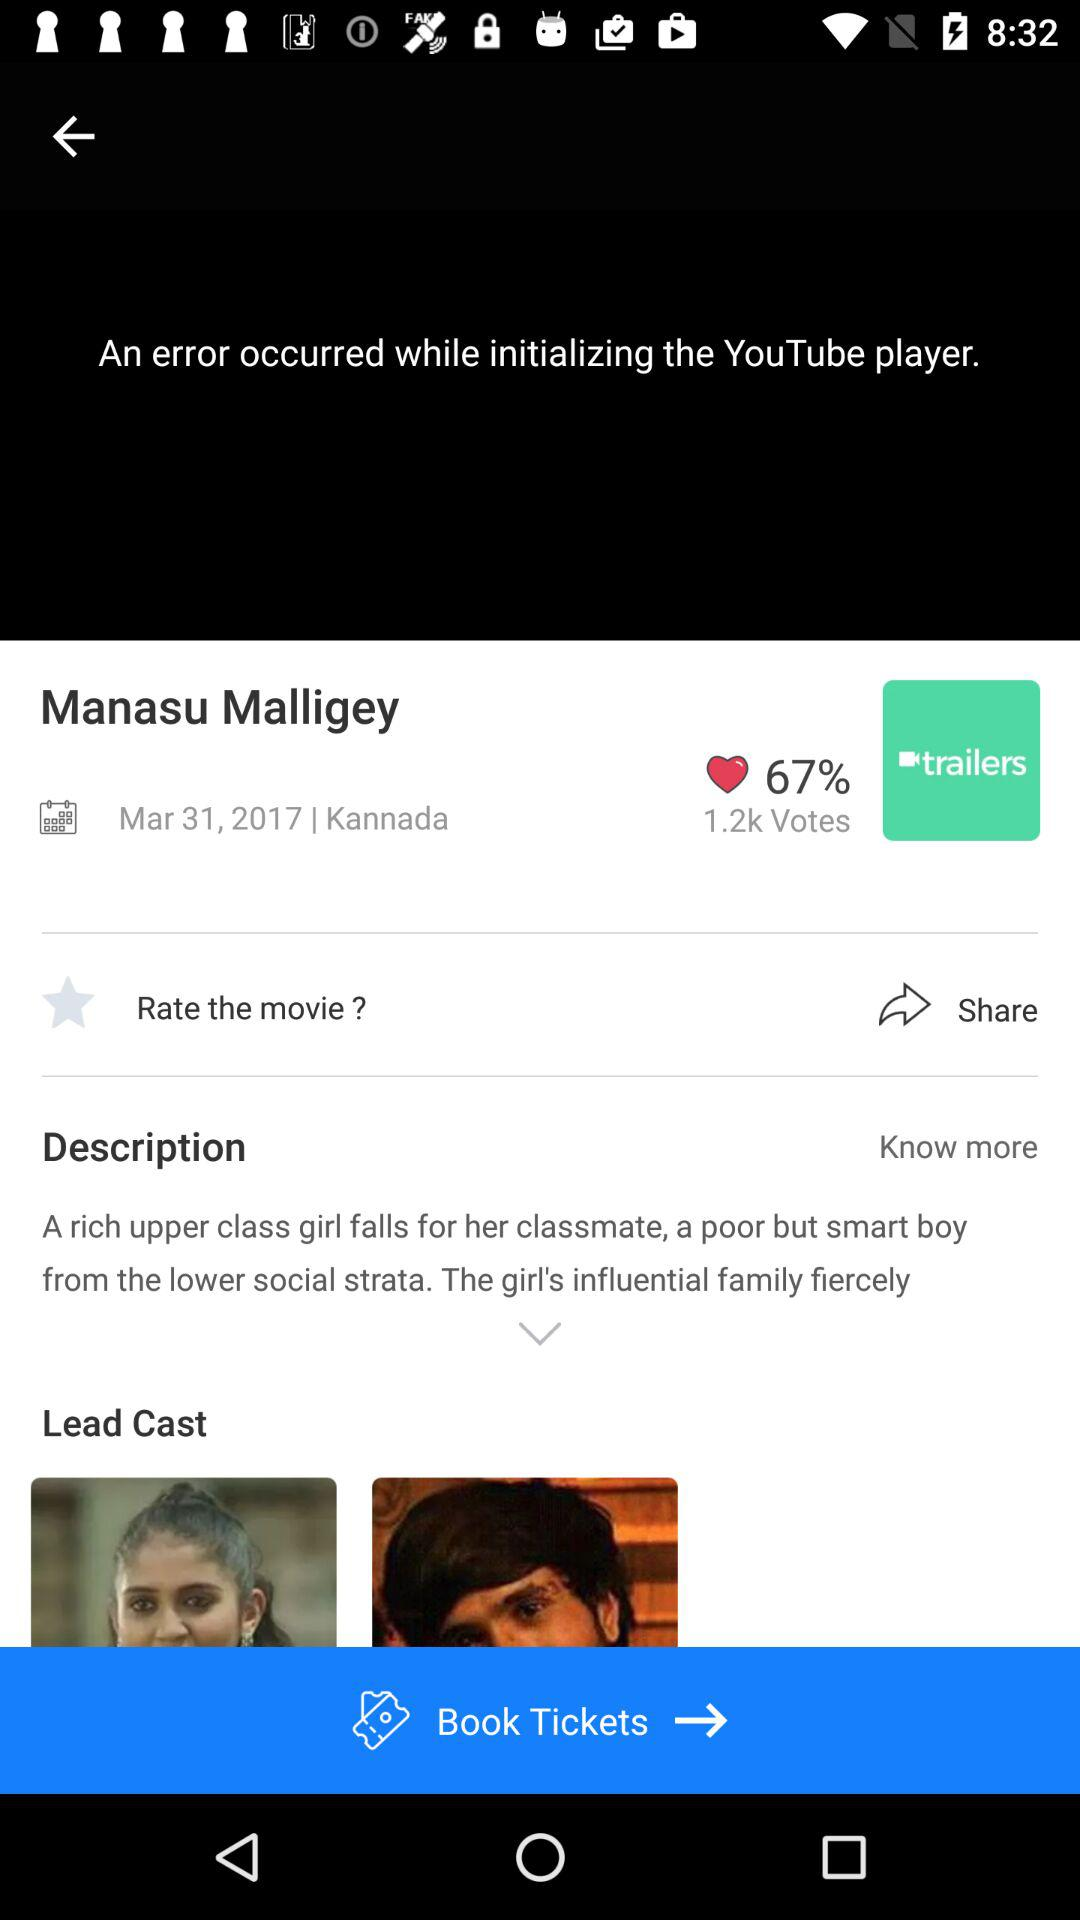What is the mentioned date? The mentioned date is March 31, 2017. 